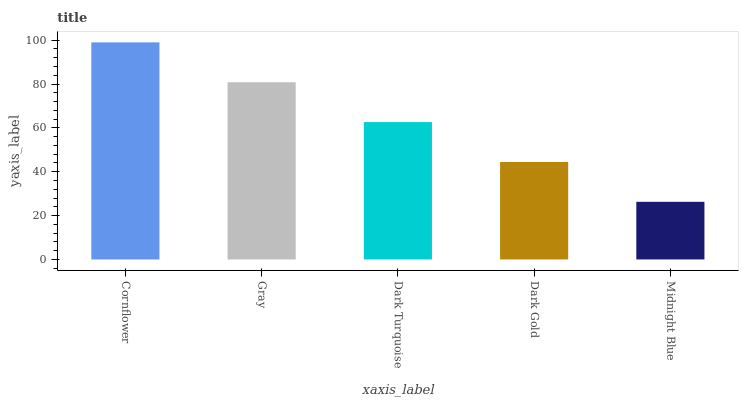Is Midnight Blue the minimum?
Answer yes or no. Yes. Is Cornflower the maximum?
Answer yes or no. Yes. Is Gray the minimum?
Answer yes or no. No. Is Gray the maximum?
Answer yes or no. No. Is Cornflower greater than Gray?
Answer yes or no. Yes. Is Gray less than Cornflower?
Answer yes or no. Yes. Is Gray greater than Cornflower?
Answer yes or no. No. Is Cornflower less than Gray?
Answer yes or no. No. Is Dark Turquoise the high median?
Answer yes or no. Yes. Is Dark Turquoise the low median?
Answer yes or no. Yes. Is Cornflower the high median?
Answer yes or no. No. Is Dark Gold the low median?
Answer yes or no. No. 